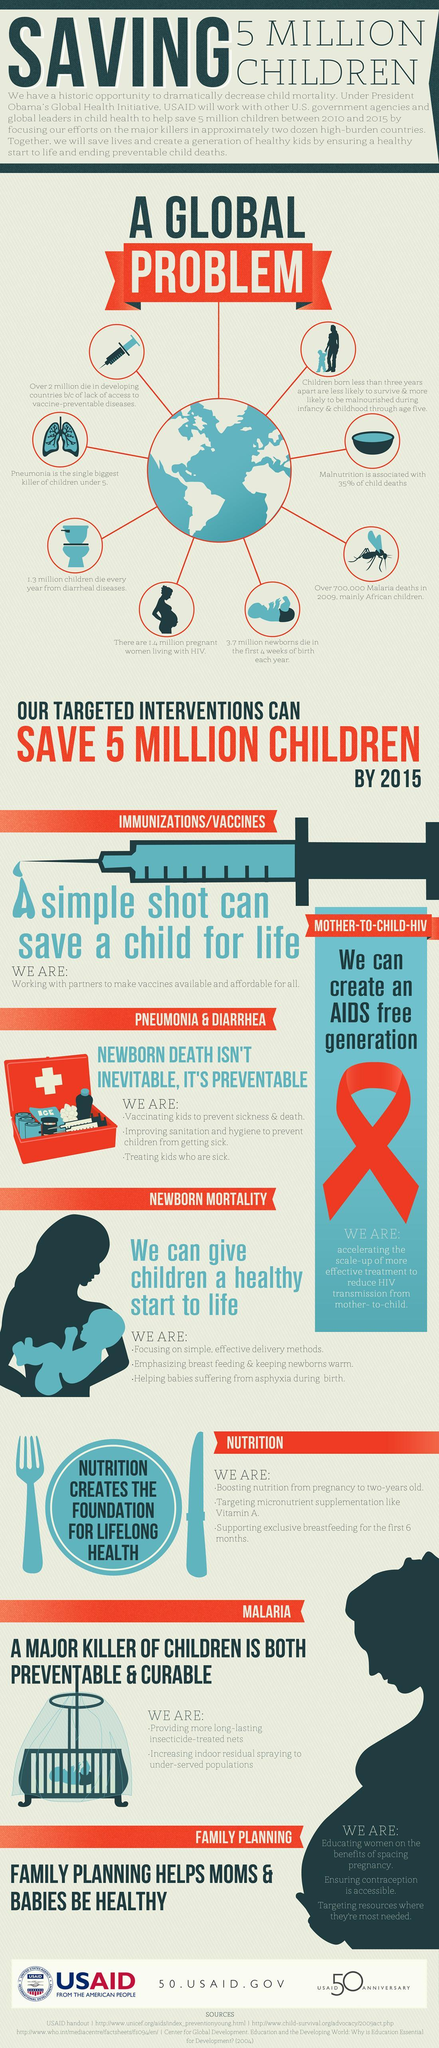Which disease can be prevented by using insecticide treated nets and indoor residual spraying?
Answer the question with a short phrase. malaria How many child deaths due to diarrheal diseases? 1.3 million What can be prevented by vaccinating, improving sanitation and hygiene conditions and providing timely treatment? newborn death What forms the base for lifelong health? Nutrition What percent of infant deaths is due to malnutrition? 35% What is the major reason for death in children under 5 years? Pneumonia How many infant deaths within the first four weeks of birth every year? 3.7 million How many deaths in developing countries due to lack of access to vaccines? 2 million Which virus can get transmitted from mother to child? HIV Which disease mentioned in this graphic is spread by mosquitoes? Malaria 